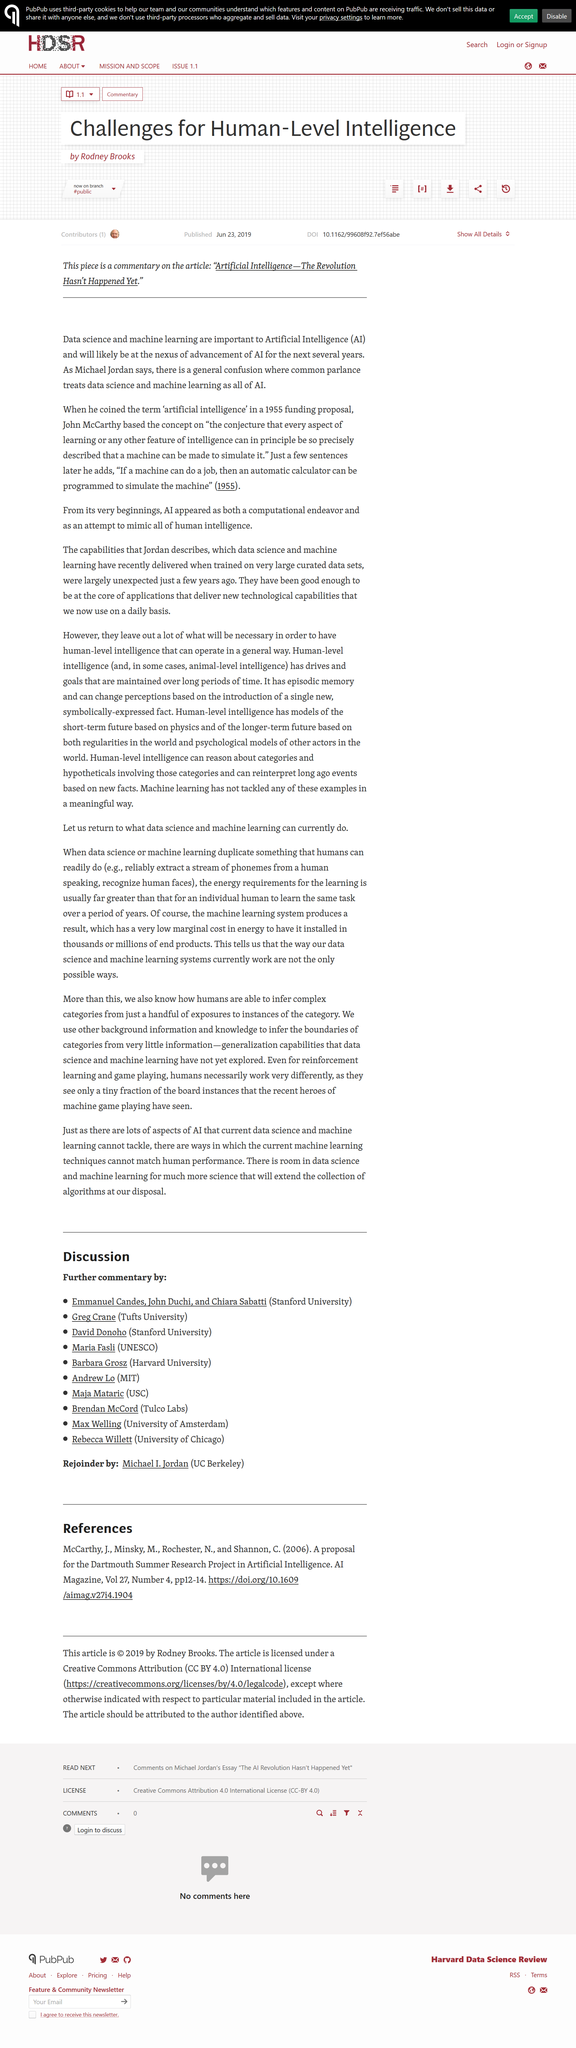Draw attention to some important aspects in this diagram. Current machine learning techniques are unable to match the human ability to infer boundaries and generalize from limited information, which is enabled by background knowledge and generalization capabilities that computers require much more data to match. Artificial intelligence is a combination of data science and machine learning, which are the foundations of its development and application. 